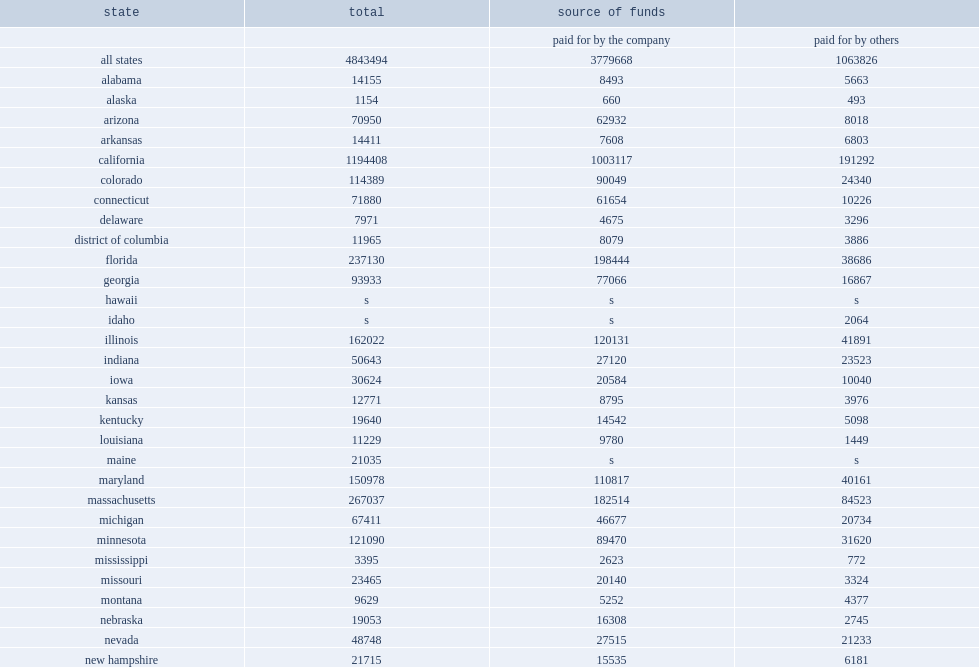How many percent of five states (california, new york, texas, massachusetts, and florida) accounted for of all r&d performance by microbusinesses in 2016? 0.493585. How many percentage points did california account of the microbusiness r&d? 0.2466. 